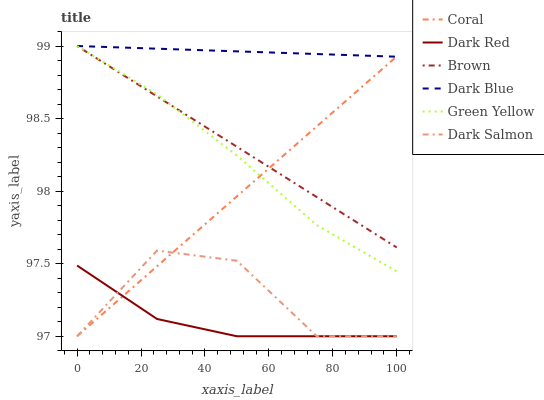Does Coral have the minimum area under the curve?
Answer yes or no. No. Does Coral have the maximum area under the curve?
Answer yes or no. No. Is Dark Red the smoothest?
Answer yes or no. No. Is Dark Red the roughest?
Answer yes or no. No. Does Dark Blue have the lowest value?
Answer yes or no. No. Does Coral have the highest value?
Answer yes or no. No. Is Dark Salmon less than Green Yellow?
Answer yes or no. Yes. Is Brown greater than Dark Salmon?
Answer yes or no. Yes. Does Dark Salmon intersect Green Yellow?
Answer yes or no. No. 